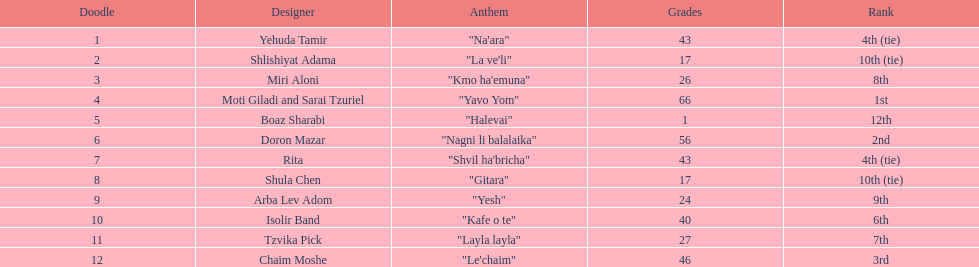What is the name of the song listed before the song "yesh"? "Gitara". 